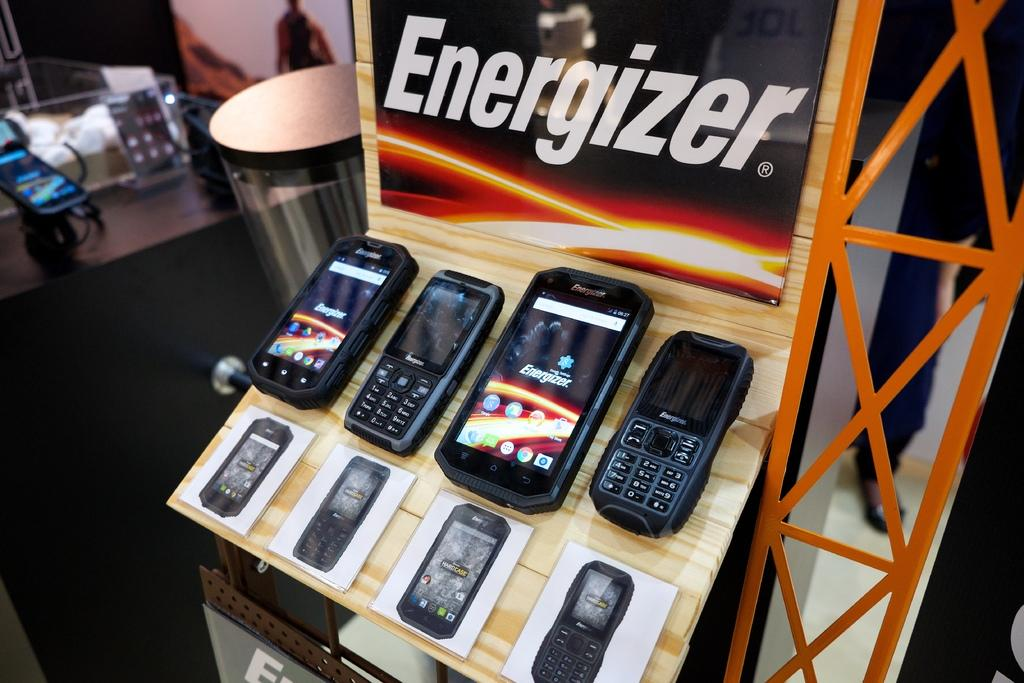<image>
Provide a brief description of the given image. The cell phone display advertises the Energizer battery brand. 